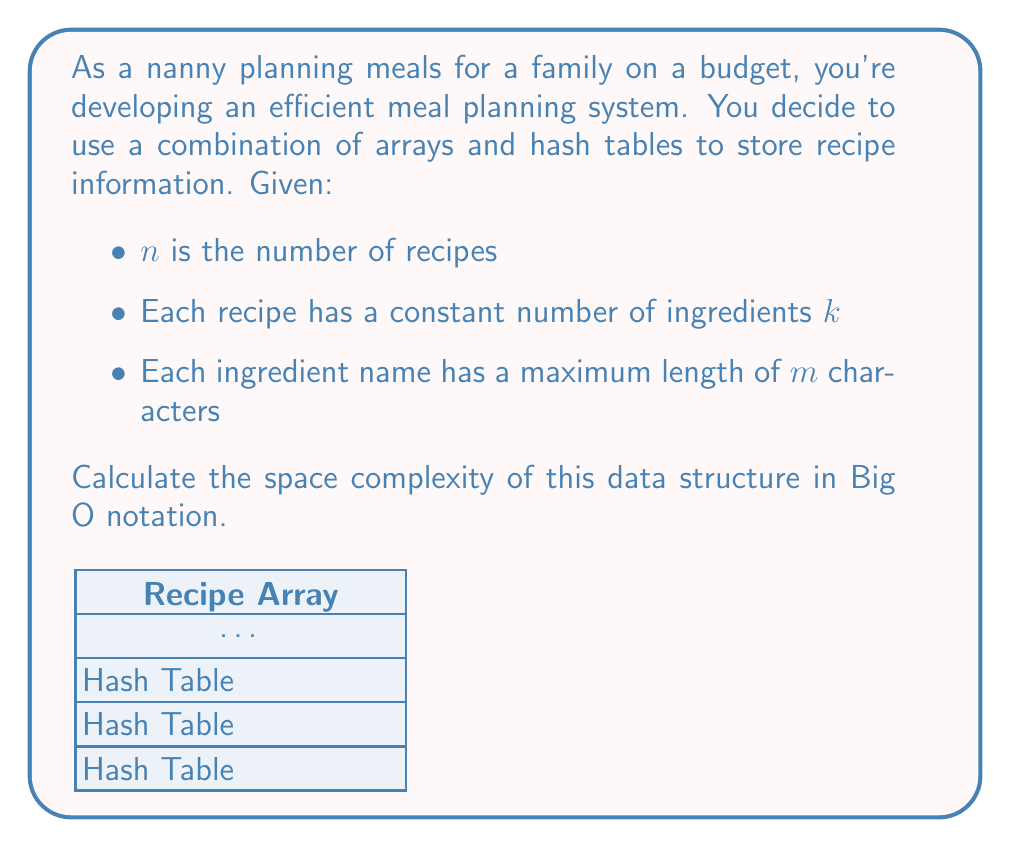Help me with this question. Let's break down the space complexity analysis step by step:

1) Recipe Array:
   - We have $n$ recipes, each stored as an element in the array.
   - Space for the array: $O(n)$

2) For each recipe, we store a hash table of ingredients:
   - Number of hash tables: $n$
   - Each hash table has $k$ entries (constant number of ingredients per recipe)
   - Space for all hash tables: $O(n * k) = O(n)$ (since $k$ is constant)

3) For each ingredient in the hash tables:
   - We store the ingredient name as a string
   - Maximum length of each ingredient name: $m$
   - Total space for all ingredient names: $O(n * k * m)$

4) Combining all components:
   - Total space = Space for recipe array + Space for hash tables + Space for ingredient names
   - $O(n) + O(n) + O(n * k * m)$
   - Simplifying: $O(n + n + nkm) = O(n + nkm)$

5) Since $k$ is constant, we can simplify further:
   $O(n + nm) = O(n(1 + m))$

This represents the overall space complexity of the data structure.
Answer: $O(n(1 + m))$ 